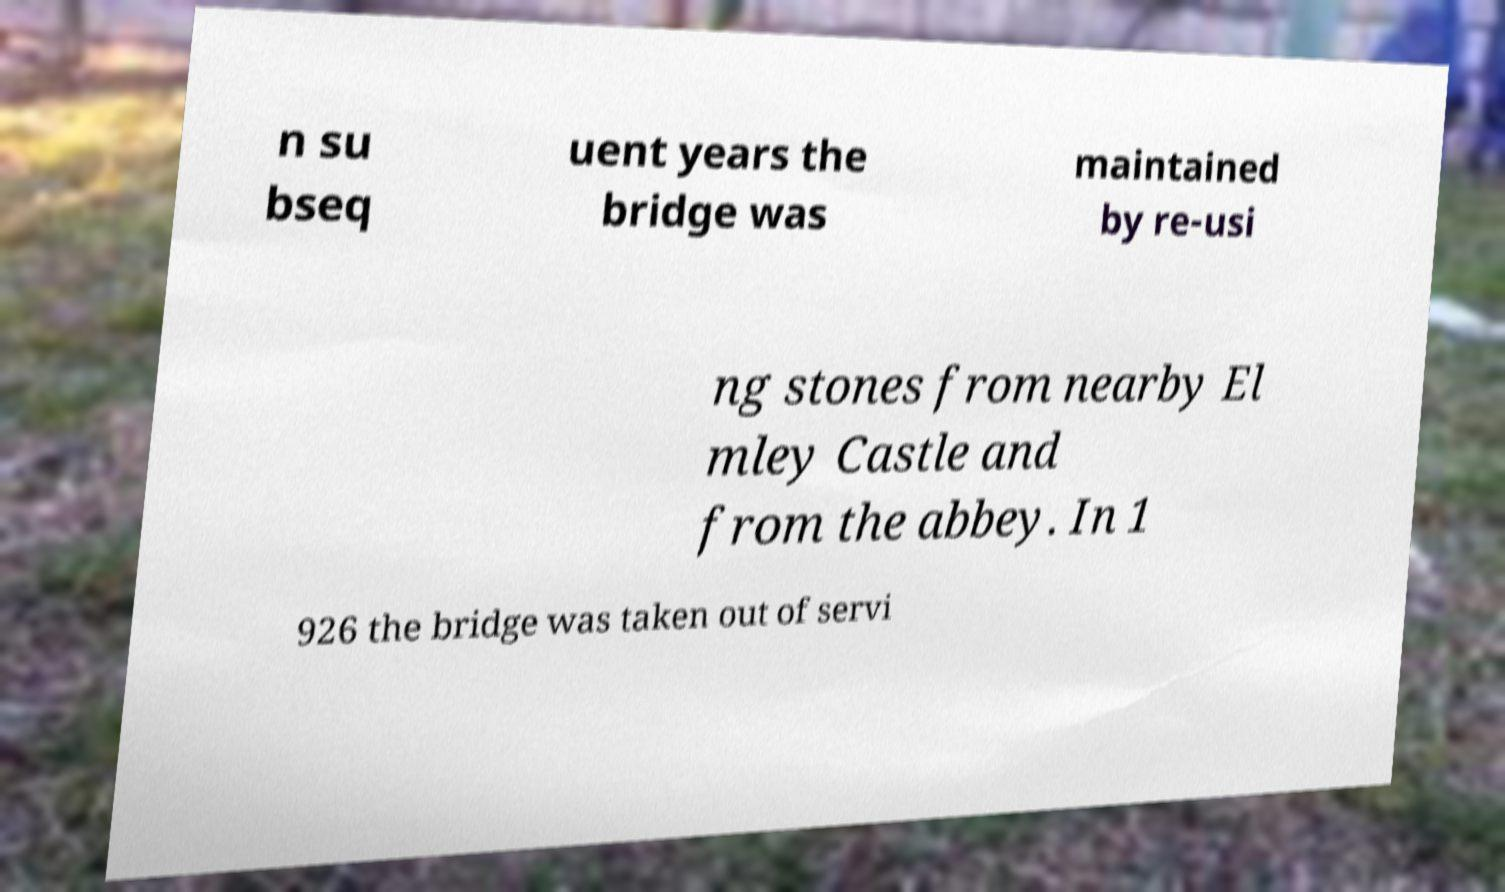Please identify and transcribe the text found in this image. n su bseq uent years the bridge was maintained by re-usi ng stones from nearby El mley Castle and from the abbey. In 1 926 the bridge was taken out of servi 